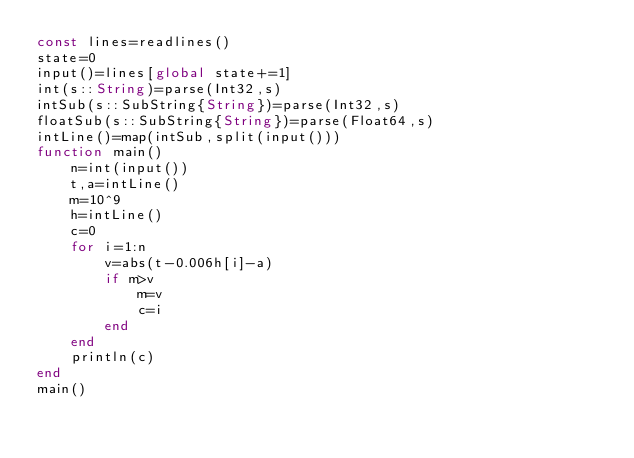<code> <loc_0><loc_0><loc_500><loc_500><_Julia_>const lines=readlines()
state=0
input()=lines[global state+=1]
int(s::String)=parse(Int32,s)
intSub(s::SubString{String})=parse(Int32,s)
floatSub(s::SubString{String})=parse(Float64,s)
intLine()=map(intSub,split(input()))
function main()
    n=int(input())
    t,a=intLine()
    m=10^9
    h=intLine()
    c=0
    for i=1:n
        v=abs(t-0.006h[i]-a)
        if m>v
            m=v
            c=i
        end
    end
    println(c)
end
main()</code> 